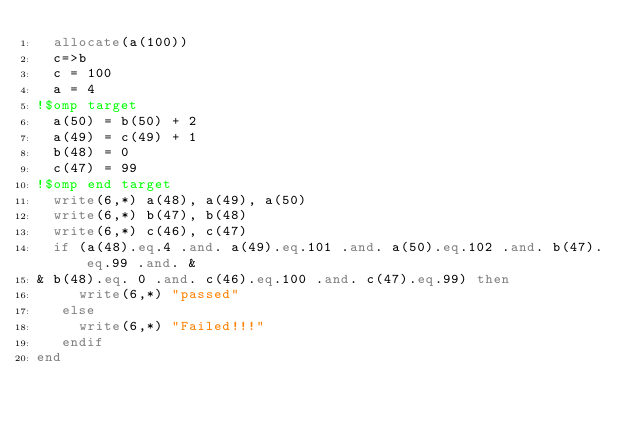Convert code to text. <code><loc_0><loc_0><loc_500><loc_500><_FORTRAN_>  allocate(a(100))
  c=>b
  c = 100
  a = 4
!$omp target 
  a(50) = b(50) + 2
  a(49) = c(49) + 1
  b(48) = 0
  c(47) = 99
!$omp end target
  write(6,*) a(48), a(49), a(50)
  write(6,*) b(47), b(48)
  write(6,*) c(46), c(47)
  if (a(48).eq.4 .and. a(49).eq.101 .and. a(50).eq.102 .and. b(47).eq.99 .and. &
& b(48).eq. 0 .and. c(46).eq.100 .and. c(47).eq.99) then
     write(6,*) "passed"
   else
     write(6,*) "Failed!!!"
   endif
end
</code> 